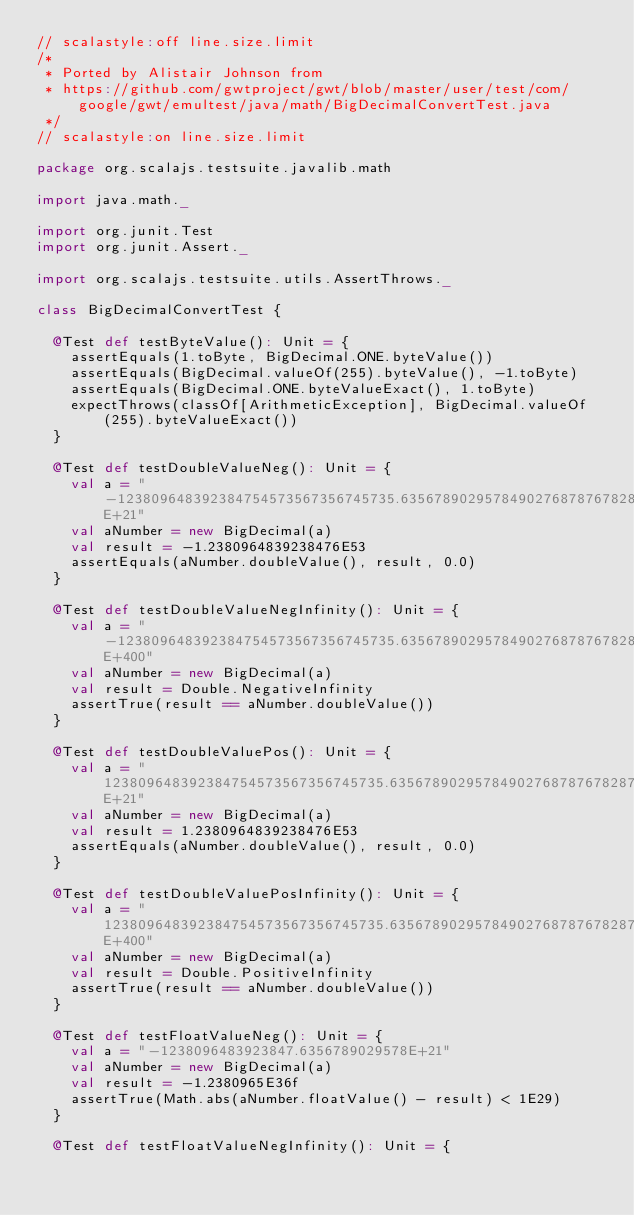Convert code to text. <code><loc_0><loc_0><loc_500><loc_500><_Scala_>// scalastyle:off line.size.limit
/*
 * Ported by Alistair Johnson from
 * https://github.com/gwtproject/gwt/blob/master/user/test/com/google/gwt/emultest/java/math/BigDecimalConvertTest.java
 */
// scalastyle:on line.size.limit

package org.scalajs.testsuite.javalib.math

import java.math._

import org.junit.Test
import org.junit.Assert._

import org.scalajs.testsuite.utils.AssertThrows._

class BigDecimalConvertTest {

  @Test def testByteValue(): Unit = {
    assertEquals(1.toByte, BigDecimal.ONE.byteValue())
    assertEquals(BigDecimal.valueOf(255).byteValue(), -1.toByte)
    assertEquals(BigDecimal.ONE.byteValueExact(), 1.toByte)
    expectThrows(classOf[ArithmeticException], BigDecimal.valueOf(255).byteValueExact())
  }

  @Test def testDoubleValueNeg(): Unit = {
    val a = "-123809648392384754573567356745735.63567890295784902768787678287E+21"
    val aNumber = new BigDecimal(a)
    val result = -1.2380964839238476E53
    assertEquals(aNumber.doubleValue(), result, 0.0)
  }

  @Test def testDoubleValueNegInfinity(): Unit = {
    val a = "-123809648392384754573567356745735.63567890295784902768787678287E+400"
    val aNumber = new BigDecimal(a)
    val result = Double.NegativeInfinity
    assertTrue(result == aNumber.doubleValue())
  }

  @Test def testDoubleValuePos(): Unit = {
    val a = "123809648392384754573567356745735.63567890295784902768787678287E+21"
    val aNumber = new BigDecimal(a)
    val result = 1.2380964839238476E53
    assertEquals(aNumber.doubleValue(), result, 0.0)
  }

  @Test def testDoubleValuePosInfinity(): Unit = {
    val a = "123809648392384754573567356745735.63567890295784902768787678287E+400"
    val aNumber = new BigDecimal(a)
    val result = Double.PositiveInfinity
    assertTrue(result == aNumber.doubleValue())
  }

  @Test def testFloatValueNeg(): Unit = {
    val a = "-1238096483923847.6356789029578E+21"
    val aNumber = new BigDecimal(a)
    val result = -1.2380965E36f
    assertTrue(Math.abs(aNumber.floatValue() - result) < 1E29)
  }

  @Test def testFloatValueNegInfinity(): Unit = {</code> 